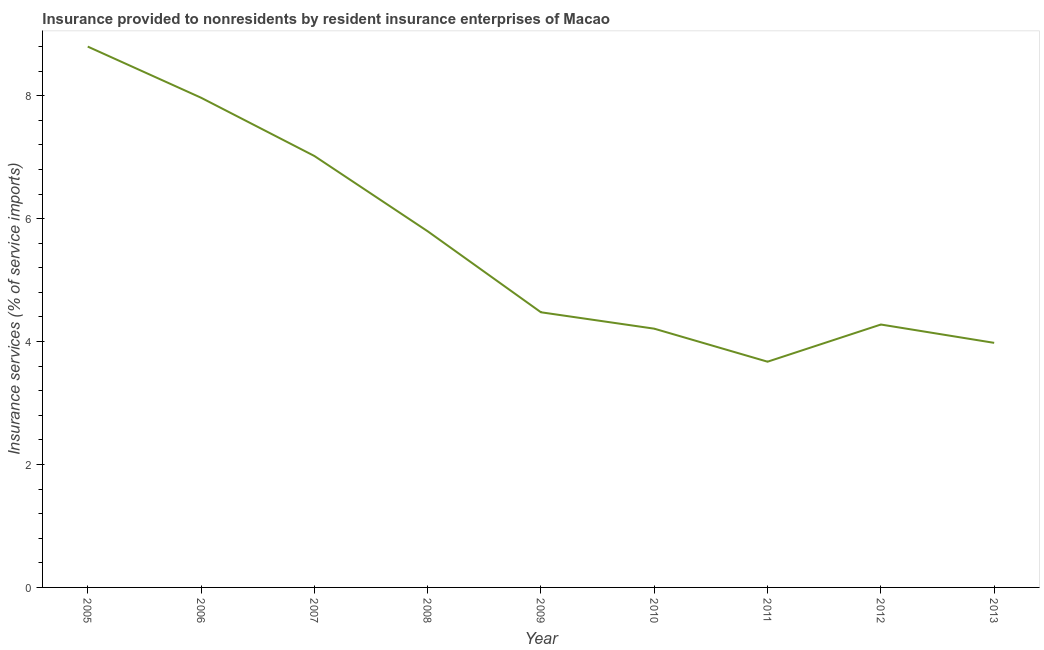What is the insurance and financial services in 2006?
Make the answer very short. 7.97. Across all years, what is the maximum insurance and financial services?
Keep it short and to the point. 8.8. Across all years, what is the minimum insurance and financial services?
Your answer should be very brief. 3.67. In which year was the insurance and financial services maximum?
Your answer should be very brief. 2005. In which year was the insurance and financial services minimum?
Keep it short and to the point. 2011. What is the sum of the insurance and financial services?
Provide a succinct answer. 50.2. What is the difference between the insurance and financial services in 2005 and 2007?
Offer a terse response. 1.78. What is the average insurance and financial services per year?
Your answer should be very brief. 5.58. What is the median insurance and financial services?
Keep it short and to the point. 4.48. What is the ratio of the insurance and financial services in 2005 to that in 2006?
Your answer should be very brief. 1.1. Is the insurance and financial services in 2008 less than that in 2009?
Offer a terse response. No. Is the difference between the insurance and financial services in 2007 and 2008 greater than the difference between any two years?
Offer a terse response. No. What is the difference between the highest and the second highest insurance and financial services?
Your answer should be compact. 0.83. What is the difference between the highest and the lowest insurance and financial services?
Your answer should be compact. 5.13. In how many years, is the insurance and financial services greater than the average insurance and financial services taken over all years?
Offer a terse response. 4. Does the insurance and financial services monotonically increase over the years?
Your answer should be compact. No. How many years are there in the graph?
Make the answer very short. 9. Are the values on the major ticks of Y-axis written in scientific E-notation?
Offer a terse response. No. Does the graph contain any zero values?
Your answer should be compact. No. Does the graph contain grids?
Ensure brevity in your answer.  No. What is the title of the graph?
Make the answer very short. Insurance provided to nonresidents by resident insurance enterprises of Macao. What is the label or title of the Y-axis?
Keep it short and to the point. Insurance services (% of service imports). What is the Insurance services (% of service imports) in 2005?
Offer a terse response. 8.8. What is the Insurance services (% of service imports) in 2006?
Your response must be concise. 7.97. What is the Insurance services (% of service imports) in 2007?
Your answer should be compact. 7.02. What is the Insurance services (% of service imports) in 2008?
Make the answer very short. 5.79. What is the Insurance services (% of service imports) of 2009?
Offer a terse response. 4.48. What is the Insurance services (% of service imports) in 2010?
Offer a terse response. 4.21. What is the Insurance services (% of service imports) of 2011?
Your response must be concise. 3.67. What is the Insurance services (% of service imports) in 2012?
Provide a succinct answer. 4.28. What is the Insurance services (% of service imports) of 2013?
Make the answer very short. 3.98. What is the difference between the Insurance services (% of service imports) in 2005 and 2006?
Offer a terse response. 0.83. What is the difference between the Insurance services (% of service imports) in 2005 and 2007?
Your response must be concise. 1.78. What is the difference between the Insurance services (% of service imports) in 2005 and 2008?
Provide a succinct answer. 3. What is the difference between the Insurance services (% of service imports) in 2005 and 2009?
Ensure brevity in your answer.  4.32. What is the difference between the Insurance services (% of service imports) in 2005 and 2010?
Your response must be concise. 4.59. What is the difference between the Insurance services (% of service imports) in 2005 and 2011?
Your answer should be very brief. 5.13. What is the difference between the Insurance services (% of service imports) in 2005 and 2012?
Offer a very short reply. 4.52. What is the difference between the Insurance services (% of service imports) in 2005 and 2013?
Make the answer very short. 4.82. What is the difference between the Insurance services (% of service imports) in 2006 and 2007?
Offer a very short reply. 0.95. What is the difference between the Insurance services (% of service imports) in 2006 and 2008?
Give a very brief answer. 2.17. What is the difference between the Insurance services (% of service imports) in 2006 and 2009?
Give a very brief answer. 3.49. What is the difference between the Insurance services (% of service imports) in 2006 and 2010?
Your answer should be compact. 3.76. What is the difference between the Insurance services (% of service imports) in 2006 and 2011?
Your answer should be compact. 4.29. What is the difference between the Insurance services (% of service imports) in 2006 and 2012?
Provide a succinct answer. 3.69. What is the difference between the Insurance services (% of service imports) in 2006 and 2013?
Your response must be concise. 3.99. What is the difference between the Insurance services (% of service imports) in 2007 and 2008?
Offer a very short reply. 1.22. What is the difference between the Insurance services (% of service imports) in 2007 and 2009?
Ensure brevity in your answer.  2.54. What is the difference between the Insurance services (% of service imports) in 2007 and 2010?
Offer a very short reply. 2.81. What is the difference between the Insurance services (% of service imports) in 2007 and 2011?
Keep it short and to the point. 3.35. What is the difference between the Insurance services (% of service imports) in 2007 and 2012?
Make the answer very short. 2.74. What is the difference between the Insurance services (% of service imports) in 2007 and 2013?
Your answer should be compact. 3.04. What is the difference between the Insurance services (% of service imports) in 2008 and 2009?
Keep it short and to the point. 1.32. What is the difference between the Insurance services (% of service imports) in 2008 and 2010?
Keep it short and to the point. 1.59. What is the difference between the Insurance services (% of service imports) in 2008 and 2011?
Provide a succinct answer. 2.12. What is the difference between the Insurance services (% of service imports) in 2008 and 2012?
Keep it short and to the point. 1.52. What is the difference between the Insurance services (% of service imports) in 2008 and 2013?
Keep it short and to the point. 1.82. What is the difference between the Insurance services (% of service imports) in 2009 and 2010?
Your response must be concise. 0.27. What is the difference between the Insurance services (% of service imports) in 2009 and 2011?
Keep it short and to the point. 0.8. What is the difference between the Insurance services (% of service imports) in 2009 and 2012?
Your response must be concise. 0.2. What is the difference between the Insurance services (% of service imports) in 2009 and 2013?
Make the answer very short. 0.5. What is the difference between the Insurance services (% of service imports) in 2010 and 2011?
Keep it short and to the point. 0.54. What is the difference between the Insurance services (% of service imports) in 2010 and 2012?
Your response must be concise. -0.07. What is the difference between the Insurance services (% of service imports) in 2010 and 2013?
Provide a short and direct response. 0.23. What is the difference between the Insurance services (% of service imports) in 2011 and 2012?
Make the answer very short. -0.6. What is the difference between the Insurance services (% of service imports) in 2011 and 2013?
Your response must be concise. -0.31. What is the difference between the Insurance services (% of service imports) in 2012 and 2013?
Offer a terse response. 0.3. What is the ratio of the Insurance services (% of service imports) in 2005 to that in 2006?
Provide a succinct answer. 1.1. What is the ratio of the Insurance services (% of service imports) in 2005 to that in 2007?
Give a very brief answer. 1.25. What is the ratio of the Insurance services (% of service imports) in 2005 to that in 2008?
Your response must be concise. 1.52. What is the ratio of the Insurance services (% of service imports) in 2005 to that in 2009?
Your response must be concise. 1.97. What is the ratio of the Insurance services (% of service imports) in 2005 to that in 2010?
Provide a succinct answer. 2.09. What is the ratio of the Insurance services (% of service imports) in 2005 to that in 2011?
Your response must be concise. 2.4. What is the ratio of the Insurance services (% of service imports) in 2005 to that in 2012?
Make the answer very short. 2.06. What is the ratio of the Insurance services (% of service imports) in 2005 to that in 2013?
Ensure brevity in your answer.  2.21. What is the ratio of the Insurance services (% of service imports) in 2006 to that in 2007?
Give a very brief answer. 1.14. What is the ratio of the Insurance services (% of service imports) in 2006 to that in 2008?
Your answer should be compact. 1.38. What is the ratio of the Insurance services (% of service imports) in 2006 to that in 2009?
Your response must be concise. 1.78. What is the ratio of the Insurance services (% of service imports) in 2006 to that in 2010?
Make the answer very short. 1.89. What is the ratio of the Insurance services (% of service imports) in 2006 to that in 2011?
Make the answer very short. 2.17. What is the ratio of the Insurance services (% of service imports) in 2006 to that in 2012?
Your response must be concise. 1.86. What is the ratio of the Insurance services (% of service imports) in 2006 to that in 2013?
Ensure brevity in your answer.  2. What is the ratio of the Insurance services (% of service imports) in 2007 to that in 2008?
Make the answer very short. 1.21. What is the ratio of the Insurance services (% of service imports) in 2007 to that in 2009?
Keep it short and to the point. 1.57. What is the ratio of the Insurance services (% of service imports) in 2007 to that in 2010?
Your answer should be compact. 1.67. What is the ratio of the Insurance services (% of service imports) in 2007 to that in 2011?
Your answer should be compact. 1.91. What is the ratio of the Insurance services (% of service imports) in 2007 to that in 2012?
Keep it short and to the point. 1.64. What is the ratio of the Insurance services (% of service imports) in 2007 to that in 2013?
Provide a short and direct response. 1.76. What is the ratio of the Insurance services (% of service imports) in 2008 to that in 2009?
Your answer should be very brief. 1.29. What is the ratio of the Insurance services (% of service imports) in 2008 to that in 2010?
Offer a terse response. 1.38. What is the ratio of the Insurance services (% of service imports) in 2008 to that in 2011?
Your response must be concise. 1.58. What is the ratio of the Insurance services (% of service imports) in 2008 to that in 2012?
Give a very brief answer. 1.35. What is the ratio of the Insurance services (% of service imports) in 2008 to that in 2013?
Your answer should be compact. 1.46. What is the ratio of the Insurance services (% of service imports) in 2009 to that in 2010?
Your answer should be compact. 1.06. What is the ratio of the Insurance services (% of service imports) in 2009 to that in 2011?
Ensure brevity in your answer.  1.22. What is the ratio of the Insurance services (% of service imports) in 2009 to that in 2012?
Make the answer very short. 1.05. What is the ratio of the Insurance services (% of service imports) in 2010 to that in 2011?
Your answer should be compact. 1.15. What is the ratio of the Insurance services (% of service imports) in 2010 to that in 2012?
Provide a short and direct response. 0.98. What is the ratio of the Insurance services (% of service imports) in 2010 to that in 2013?
Provide a short and direct response. 1.06. What is the ratio of the Insurance services (% of service imports) in 2011 to that in 2012?
Keep it short and to the point. 0.86. What is the ratio of the Insurance services (% of service imports) in 2011 to that in 2013?
Make the answer very short. 0.92. What is the ratio of the Insurance services (% of service imports) in 2012 to that in 2013?
Offer a very short reply. 1.07. 